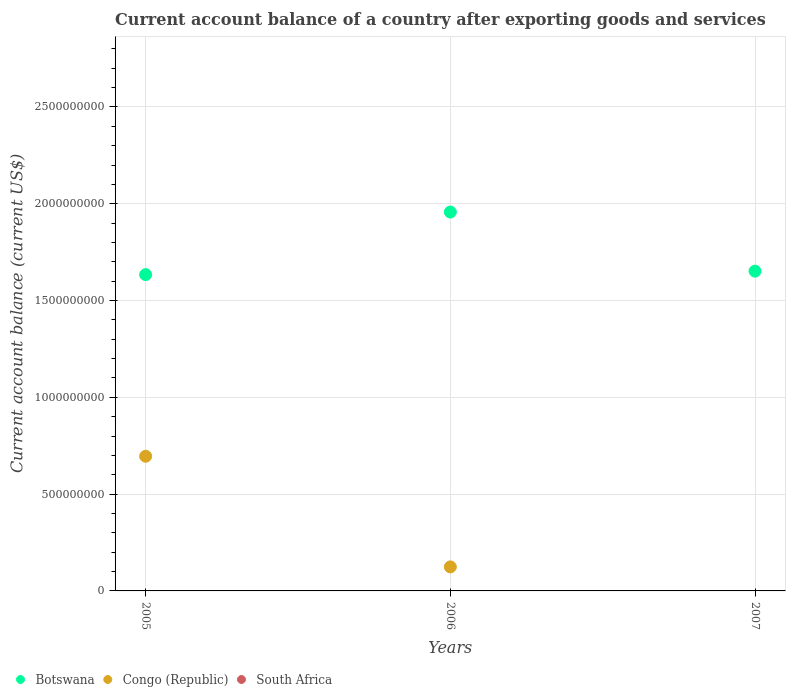Is the number of dotlines equal to the number of legend labels?
Ensure brevity in your answer.  No. Across all years, what is the maximum account balance in Congo (Republic)?
Your response must be concise. 6.96e+08. In which year was the account balance in Congo (Republic) maximum?
Make the answer very short. 2005. What is the total account balance in Botswana in the graph?
Provide a short and direct response. 5.24e+09. What is the difference between the account balance in Botswana in 2005 and that in 2007?
Your answer should be compact. -1.79e+07. What is the difference between the account balance in Congo (Republic) in 2005 and the account balance in Botswana in 2007?
Your answer should be very brief. -9.56e+08. What is the average account balance in Botswana per year?
Your answer should be compact. 1.75e+09. In the year 2005, what is the difference between the account balance in Congo (Republic) and account balance in Botswana?
Provide a succinct answer. -9.38e+08. In how many years, is the account balance in Botswana greater than 1600000000 US$?
Your answer should be very brief. 3. What is the ratio of the account balance in Botswana in 2005 to that in 2007?
Provide a succinct answer. 0.99. Is the difference between the account balance in Congo (Republic) in 2005 and 2006 greater than the difference between the account balance in Botswana in 2005 and 2006?
Make the answer very short. Yes. What is the difference between the highest and the second highest account balance in Botswana?
Your response must be concise. 3.05e+08. What is the difference between the highest and the lowest account balance in Congo (Republic)?
Your answer should be compact. 6.96e+08. Is the account balance in Botswana strictly greater than the account balance in South Africa over the years?
Your answer should be very brief. Yes. Is the account balance in South Africa strictly less than the account balance in Botswana over the years?
Keep it short and to the point. Yes. How many years are there in the graph?
Ensure brevity in your answer.  3. Does the graph contain any zero values?
Offer a terse response. Yes. How are the legend labels stacked?
Offer a very short reply. Horizontal. What is the title of the graph?
Offer a very short reply. Current account balance of a country after exporting goods and services. Does "Zimbabwe" appear as one of the legend labels in the graph?
Provide a short and direct response. No. What is the label or title of the Y-axis?
Make the answer very short. Current account balance (current US$). What is the Current account balance (current US$) of Botswana in 2005?
Your answer should be compact. 1.63e+09. What is the Current account balance (current US$) of Congo (Republic) in 2005?
Your response must be concise. 6.96e+08. What is the Current account balance (current US$) in South Africa in 2005?
Make the answer very short. 0. What is the Current account balance (current US$) in Botswana in 2006?
Ensure brevity in your answer.  1.96e+09. What is the Current account balance (current US$) of Congo (Republic) in 2006?
Give a very brief answer. 1.24e+08. What is the Current account balance (current US$) in Botswana in 2007?
Offer a very short reply. 1.65e+09. What is the Current account balance (current US$) in South Africa in 2007?
Give a very brief answer. 0. Across all years, what is the maximum Current account balance (current US$) of Botswana?
Your response must be concise. 1.96e+09. Across all years, what is the maximum Current account balance (current US$) of Congo (Republic)?
Your answer should be very brief. 6.96e+08. Across all years, what is the minimum Current account balance (current US$) of Botswana?
Your answer should be compact. 1.63e+09. What is the total Current account balance (current US$) in Botswana in the graph?
Your response must be concise. 5.24e+09. What is the total Current account balance (current US$) of Congo (Republic) in the graph?
Your answer should be very brief. 8.20e+08. What is the total Current account balance (current US$) in South Africa in the graph?
Your answer should be very brief. 0. What is the difference between the Current account balance (current US$) of Botswana in 2005 and that in 2006?
Offer a terse response. -3.23e+08. What is the difference between the Current account balance (current US$) of Congo (Republic) in 2005 and that in 2006?
Offer a terse response. 5.71e+08. What is the difference between the Current account balance (current US$) of Botswana in 2005 and that in 2007?
Offer a very short reply. -1.79e+07. What is the difference between the Current account balance (current US$) of Botswana in 2006 and that in 2007?
Give a very brief answer. 3.05e+08. What is the difference between the Current account balance (current US$) of Botswana in 2005 and the Current account balance (current US$) of Congo (Republic) in 2006?
Provide a succinct answer. 1.51e+09. What is the average Current account balance (current US$) in Botswana per year?
Make the answer very short. 1.75e+09. What is the average Current account balance (current US$) in Congo (Republic) per year?
Make the answer very short. 2.73e+08. In the year 2005, what is the difference between the Current account balance (current US$) in Botswana and Current account balance (current US$) in Congo (Republic)?
Your answer should be very brief. 9.38e+08. In the year 2006, what is the difference between the Current account balance (current US$) of Botswana and Current account balance (current US$) of Congo (Republic)?
Make the answer very short. 1.83e+09. What is the ratio of the Current account balance (current US$) of Botswana in 2005 to that in 2006?
Offer a terse response. 0.83. What is the ratio of the Current account balance (current US$) of Congo (Republic) in 2005 to that in 2006?
Give a very brief answer. 5.6. What is the ratio of the Current account balance (current US$) in Botswana in 2005 to that in 2007?
Ensure brevity in your answer.  0.99. What is the ratio of the Current account balance (current US$) of Botswana in 2006 to that in 2007?
Make the answer very short. 1.18. What is the difference between the highest and the second highest Current account balance (current US$) in Botswana?
Offer a very short reply. 3.05e+08. What is the difference between the highest and the lowest Current account balance (current US$) of Botswana?
Offer a terse response. 3.23e+08. What is the difference between the highest and the lowest Current account balance (current US$) of Congo (Republic)?
Offer a terse response. 6.96e+08. 